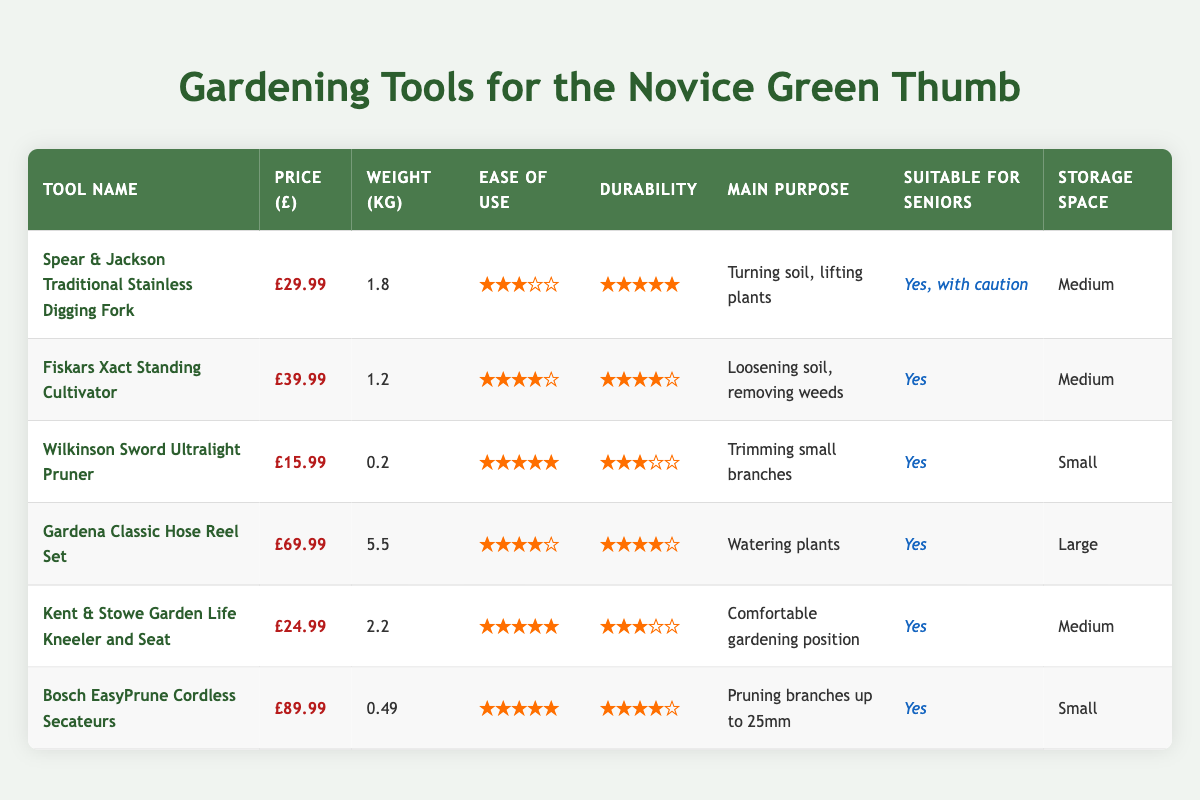What is the price of the Wilkinson Sword Ultralight Pruner? The price of the Wilkinson Sword Ultralight Pruner is listed in the table under the "Price (£)" column. It shows £15.99.
Answer: £15.99 Which tool has the highest durability rating? The durability ratings are found in the "Durability (1-5)" column, where each tool is rated. The highest rating is 5, which is assigned to both the Spear & Jackson Traditional Stainless Digging Fork and the Wilkinson Sword Ultralight Pruner, but the digging fork also has a weight and purpose that may be more suitable for heavier tasks.
Answer: Spear & Jackson Traditional Stainless Digging Fork Is the Gardena Classic Hose Reel Set suitable for seniors? The suitability for seniors is indicated in the "Suitable for Seniors" column. The Gardena Classic Hose Reel Set is marked as "Yes."
Answer: Yes What is the average weight of the tools listed in the table? The tools’ weights are 1.8 kg, 1.2 kg, 0.2 kg, 5.5 kg, 2.2 kg, and 0.49 kg. The total weight is (1.8 + 1.2 + 0.2 + 5.5 + 2.2 + 0.49) = 11.41 kg. There are 6 tools, so the average weight is 11.41 kg / 6 = 1.90 kg.
Answer: 1.90 kg Which tool requires the most storage space? To find the tool that requires the most storage space, we look at the "Storage Space Required" column. The Gardena Classic Hose Reel Set is marked as requiring "Large" storage space, which is the most compared to the other tools in the list.
Answer: Gardena Classic Hose Reel Set How many tools have an ease of use rating of 5? The "Ease of Use (1-5)" column shows the ratings. The tools with a rating of 5 are the Wilkinson Sword Ultralight Pruner, Kent & Stowe Garden Life Kneeler and Seat, and Bosch EasyPrune Cordless Secateurs. There are 3 tools with an ease of use rating of 5.
Answer: 3 Does the Fiskars Xact Standing Cultivator have a higher ease of use rating than the Spear & Jackson Traditional Stainless Digging Fork? Looking at the "Ease of Use (1-5)" column, the Fiskars Xact Standing Cultivator has a rating of 4, while the Spear & Jackson Traditional Stainless Digging Fork has a rating of 3. Therefore, the Fiskars tool has a higher rating.
Answer: Yes Which tool has the lowest price, and how much is it? The prices of the tools are listed in the "Price (£)" column. The lowest price is found beside the Wilkinson Sword Ultralight Pruner, which is £15.99.
Answer: £15.99 